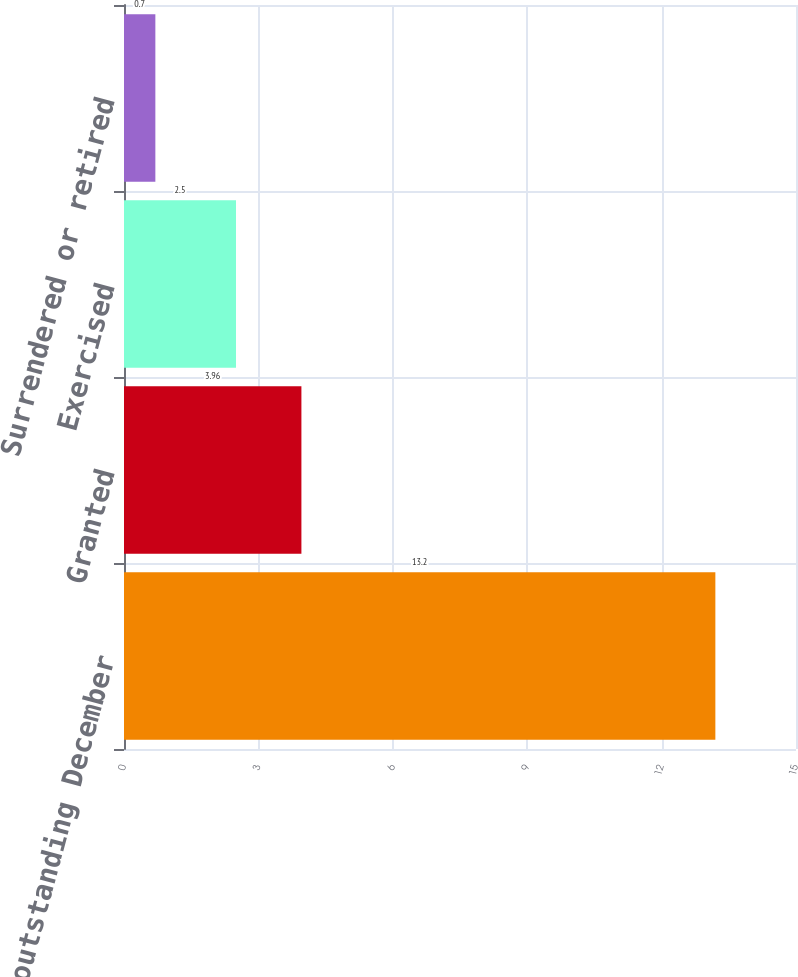<chart> <loc_0><loc_0><loc_500><loc_500><bar_chart><fcel>Options outstanding December<fcel>Granted<fcel>Exercised<fcel>Surrendered or retired<nl><fcel>13.2<fcel>3.96<fcel>2.5<fcel>0.7<nl></chart> 